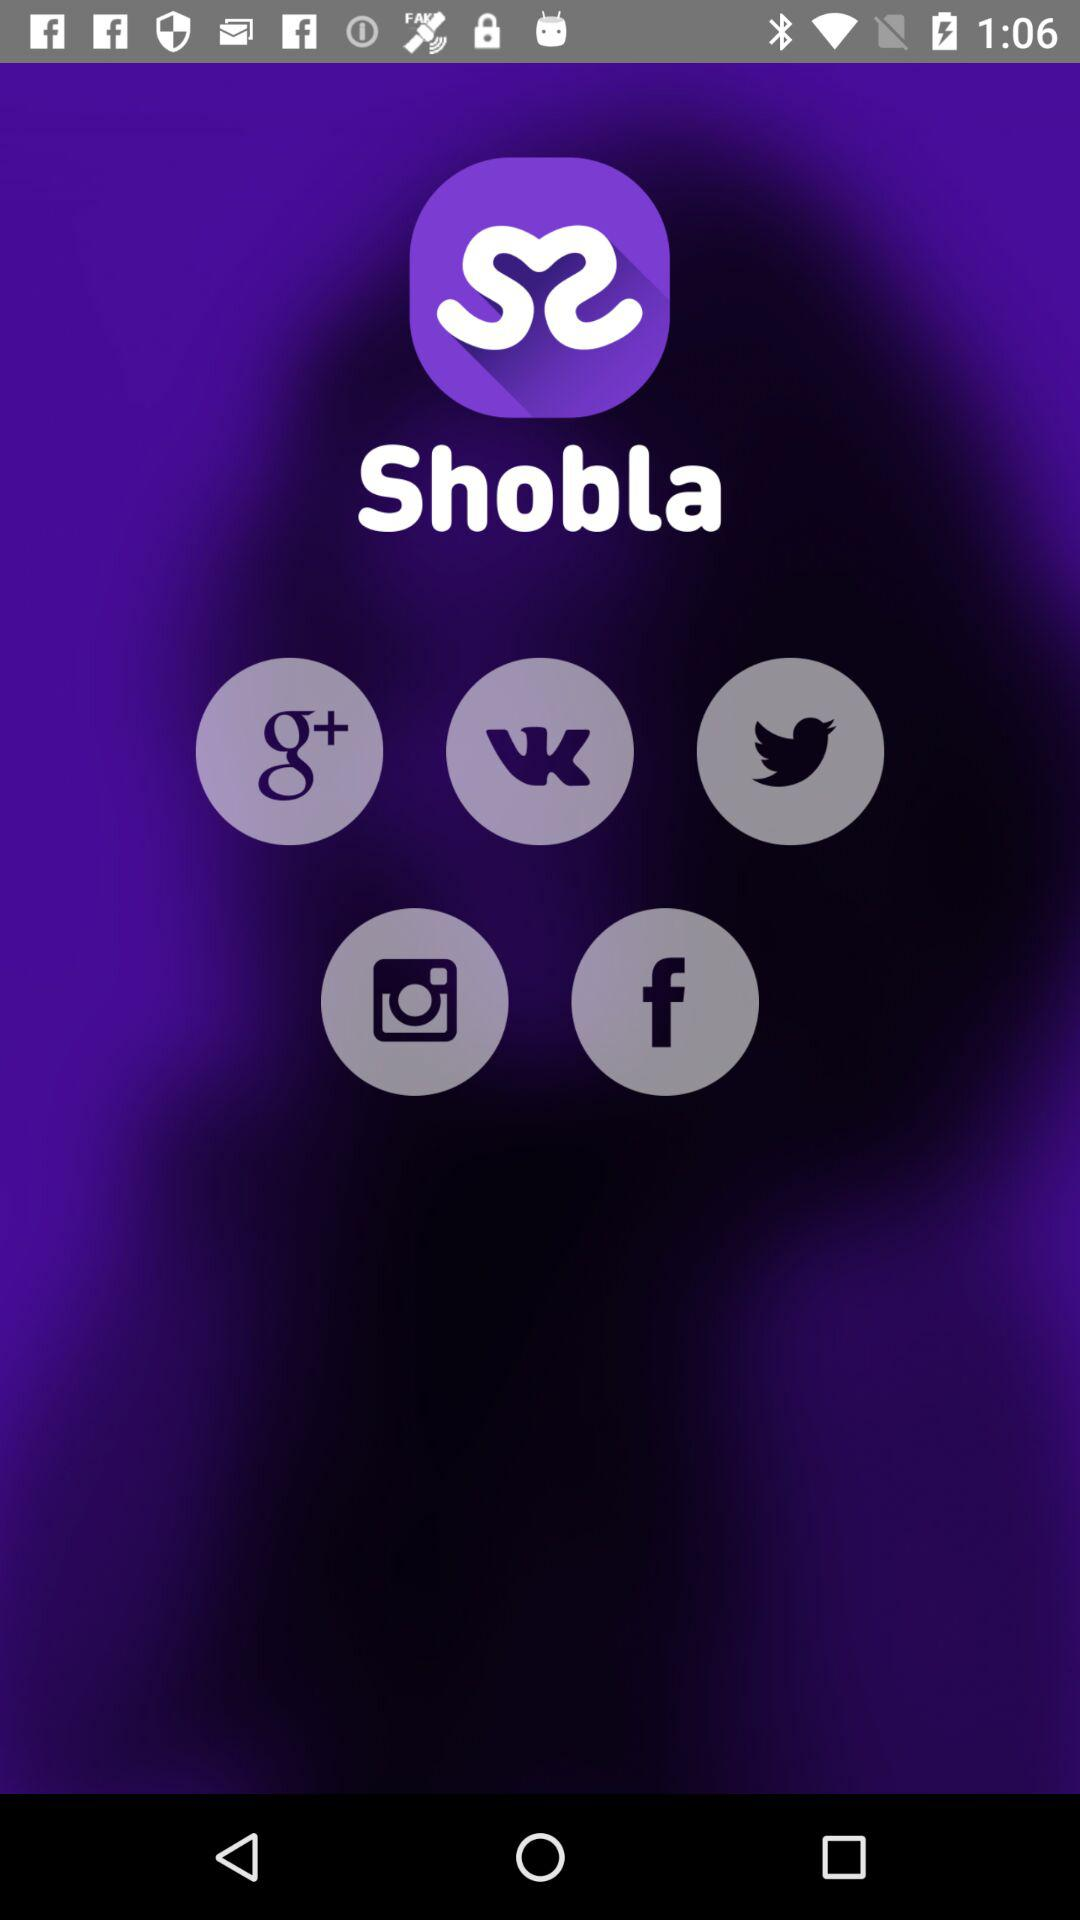What’s the app name? The app name is "Shobla". 